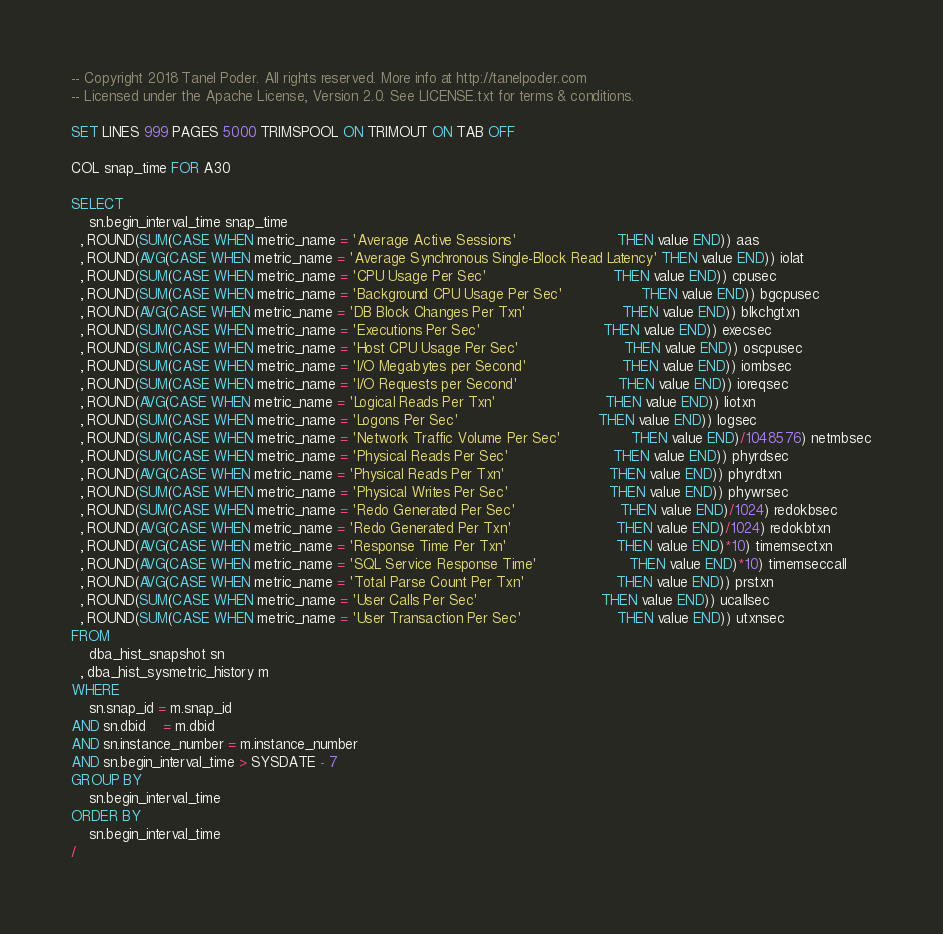<code> <loc_0><loc_0><loc_500><loc_500><_SQL_>-- Copyright 2018 Tanel Poder. All rights reserved. More info at http://tanelpoder.com
-- Licensed under the Apache License, Version 2.0. See LICENSE.txt for terms & conditions.

SET LINES 999 PAGES 5000 TRIMSPOOL ON TRIMOUT ON TAB OFF

COL snap_time FOR A30

SELECT
    sn.begin_interval_time snap_time
  , ROUND(SUM(CASE WHEN metric_name = 'Average Active Sessions'                       THEN value END)) aas
  , ROUND(AVG(CASE WHEN metric_name = 'Average Synchronous Single-Block Read Latency' THEN value END)) iolat
  , ROUND(SUM(CASE WHEN metric_name = 'CPU Usage Per Sec'                             THEN value END)) cpusec
  , ROUND(SUM(CASE WHEN metric_name = 'Background CPU Usage Per Sec'                  THEN value END)) bgcpusec
  , ROUND(AVG(CASE WHEN metric_name = 'DB Block Changes Per Txn'                      THEN value END)) blkchgtxn
  , ROUND(SUM(CASE WHEN metric_name = 'Executions Per Sec'                            THEN value END)) execsec
  , ROUND(SUM(CASE WHEN metric_name = 'Host CPU Usage Per Sec'                        THEN value END)) oscpusec 
  , ROUND(SUM(CASE WHEN metric_name = 'I/O Megabytes per Second'                      THEN value END)) iombsec
  , ROUND(SUM(CASE WHEN metric_name = 'I/O Requests per Second'                       THEN value END)) ioreqsec
  , ROUND(AVG(CASE WHEN metric_name = 'Logical Reads Per Txn'                         THEN value END)) liotxn
  , ROUND(SUM(CASE WHEN metric_name = 'Logons Per Sec'                                THEN value END)) logsec
  , ROUND(SUM(CASE WHEN metric_name = 'Network Traffic Volume Per Sec'                THEN value END)/1048576) netmbsec
  , ROUND(SUM(CASE WHEN metric_name = 'Physical Reads Per Sec'                        THEN value END)) phyrdsec
  , ROUND(AVG(CASE WHEN metric_name = 'Physical Reads Per Txn'                        THEN value END)) phyrdtxn
  , ROUND(SUM(CASE WHEN metric_name = 'Physical Writes Per Sec'                       THEN value END)) phywrsec
  , ROUND(SUM(CASE WHEN metric_name = 'Redo Generated Per Sec'                        THEN value END)/1024) redokbsec
  , ROUND(AVG(CASE WHEN metric_name = 'Redo Generated Per Txn'                        THEN value END)/1024) redokbtxn
  , ROUND(AVG(CASE WHEN metric_name = 'Response Time Per Txn'                         THEN value END)*10) timemsectxn
  , ROUND(AVG(CASE WHEN metric_name = 'SQL Service Response Time'                     THEN value END)*10) timemseccall
  , ROUND(AVG(CASE WHEN metric_name = 'Total Parse Count Per Txn'                     THEN value END)) prstxn
  , ROUND(SUM(CASE WHEN metric_name = 'User Calls Per Sec'                            THEN value END)) ucallsec
  , ROUND(SUM(CASE WHEN metric_name = 'User Transaction Per Sec'                      THEN value END)) utxnsec
FROM
    dba_hist_snapshot sn
  , dba_hist_sysmetric_history m
WHERE
    sn.snap_id = m.snap_id
AND sn.dbid    = m.dbid
AND sn.instance_number = m.instance_number
AND sn.begin_interval_time > SYSDATE - 7
GROUP BY
    sn.begin_interval_time
ORDER BY
    sn.begin_interval_time
/

</code> 